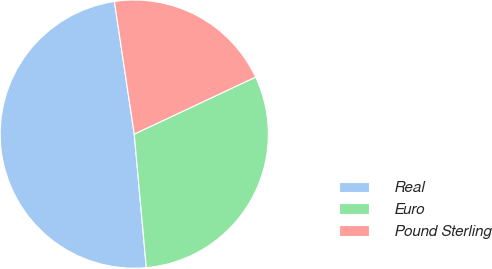Convert chart. <chart><loc_0><loc_0><loc_500><loc_500><pie_chart><fcel>Real<fcel>Euro<fcel>Pound Sterling<nl><fcel>49.07%<fcel>30.56%<fcel>20.37%<nl></chart> 